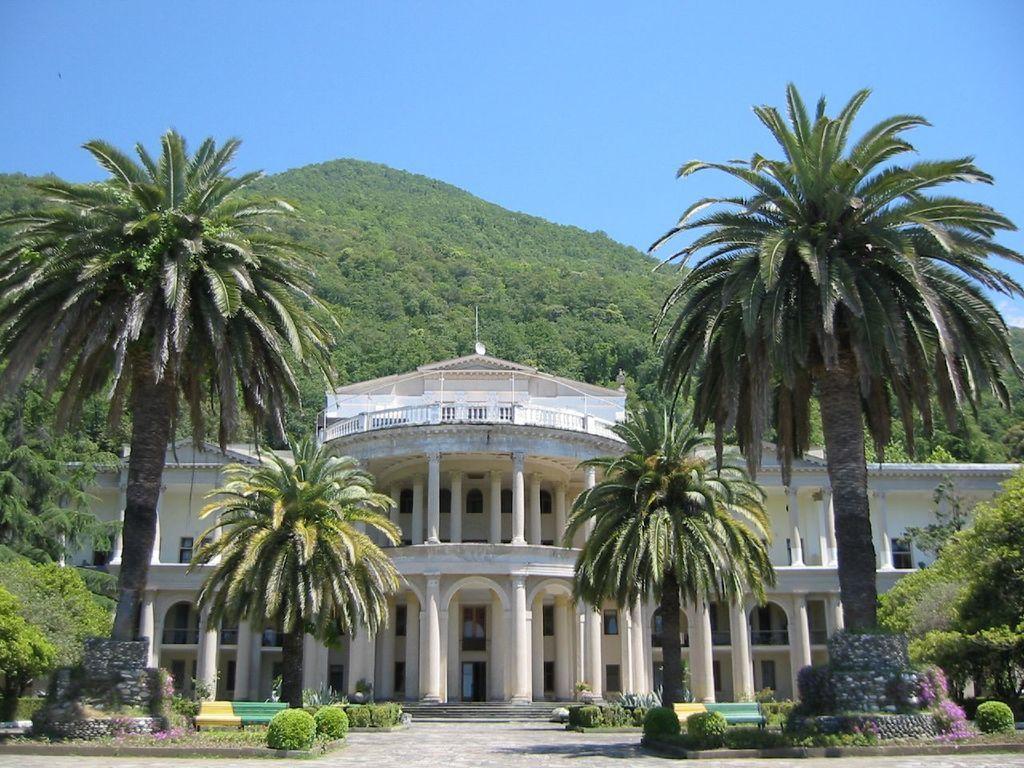Describe this image in one or two sentences. This picture shows a building and we see trees and a hill and we see a blue sky and few plants. 